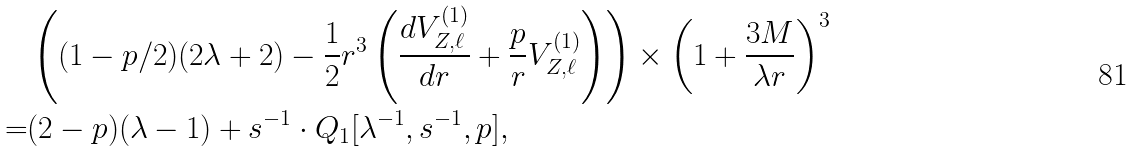Convert formula to latex. <formula><loc_0><loc_0><loc_500><loc_500>& \left ( ( 1 - p / 2 ) ( 2 \lambda + 2 ) - \frac { 1 } { 2 } r ^ { 3 } \left ( \frac { d V _ { Z , \ell } ^ { ( 1 ) } } { d r } + \frac { p } { r } V _ { Z , \ell } ^ { ( 1 ) } \right ) \right ) \times \left ( 1 + \frac { 3 M } { \lambda r } \right ) ^ { 3 } \\ = & ( 2 - p ) ( \lambda - 1 ) + s ^ { - 1 } \cdot Q _ { 1 } [ \lambda ^ { - 1 } , s ^ { - 1 } , p ] ,</formula> 